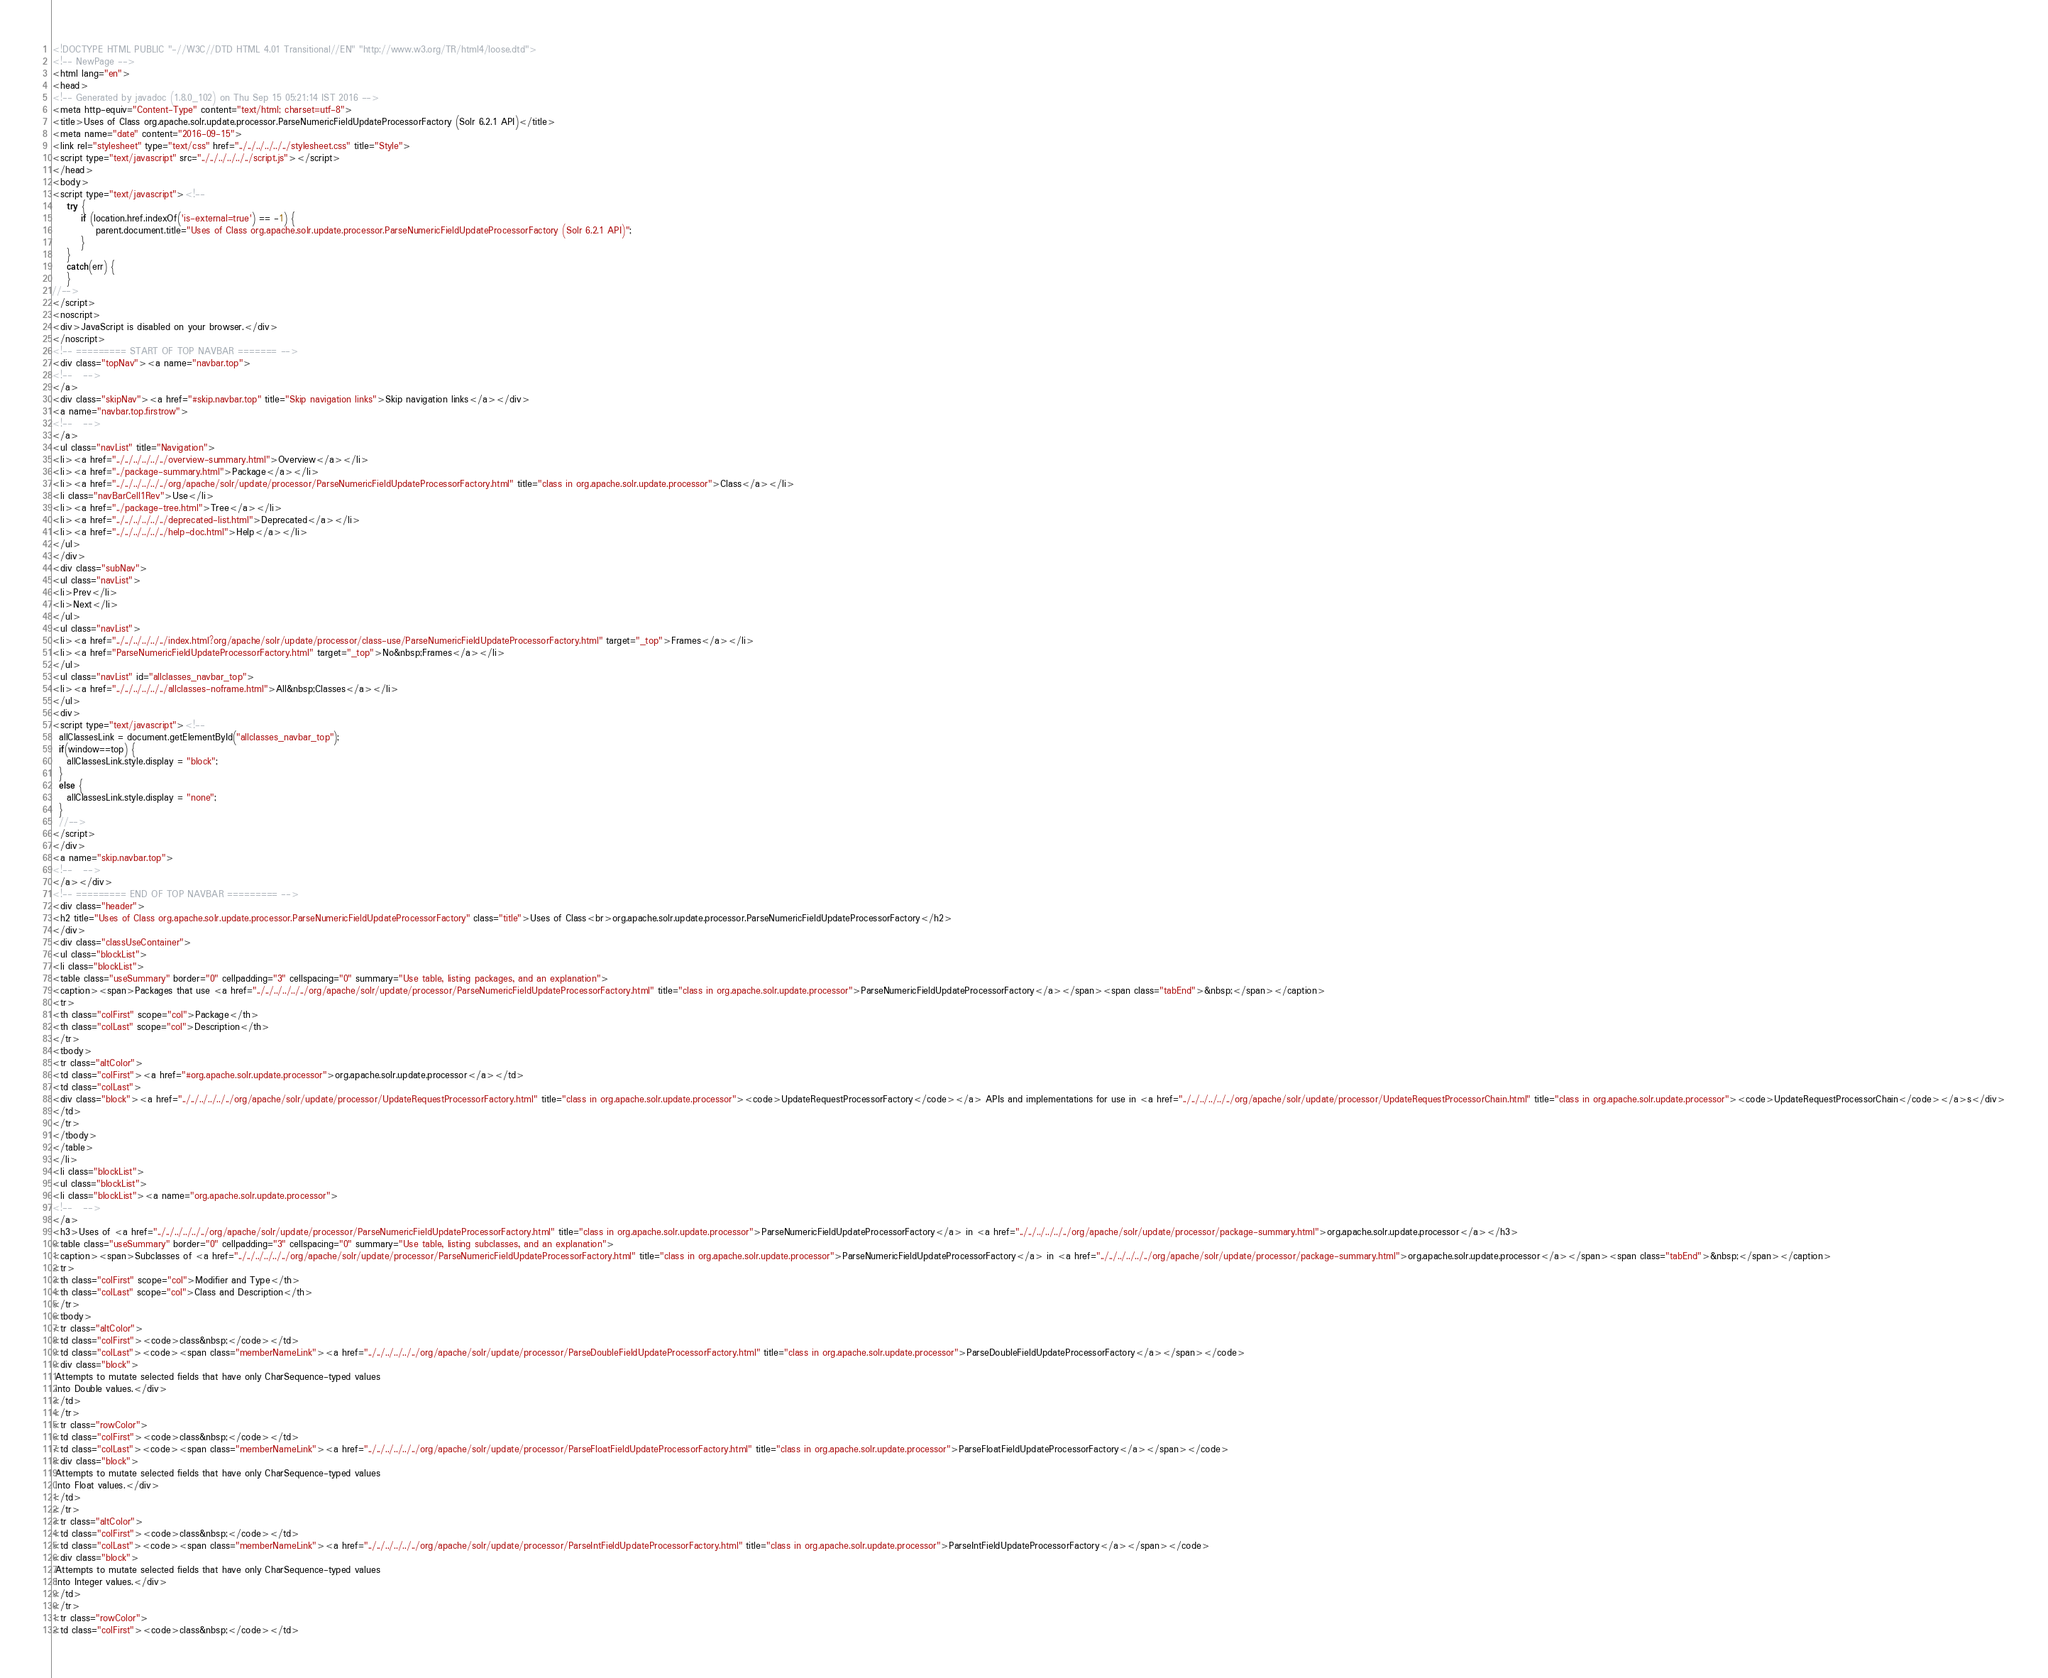<code> <loc_0><loc_0><loc_500><loc_500><_HTML_><!DOCTYPE HTML PUBLIC "-//W3C//DTD HTML 4.01 Transitional//EN" "http://www.w3.org/TR/html4/loose.dtd">
<!-- NewPage -->
<html lang="en">
<head>
<!-- Generated by javadoc (1.8.0_102) on Thu Sep 15 05:21:14 IST 2016 -->
<meta http-equiv="Content-Type" content="text/html; charset=utf-8">
<title>Uses of Class org.apache.solr.update.processor.ParseNumericFieldUpdateProcessorFactory (Solr 6.2.1 API)</title>
<meta name="date" content="2016-09-15">
<link rel="stylesheet" type="text/css" href="../../../../../../stylesheet.css" title="Style">
<script type="text/javascript" src="../../../../../../script.js"></script>
</head>
<body>
<script type="text/javascript"><!--
    try {
        if (location.href.indexOf('is-external=true') == -1) {
            parent.document.title="Uses of Class org.apache.solr.update.processor.ParseNumericFieldUpdateProcessorFactory (Solr 6.2.1 API)";
        }
    }
    catch(err) {
    }
//-->
</script>
<noscript>
<div>JavaScript is disabled on your browser.</div>
</noscript>
<!-- ========= START OF TOP NAVBAR ======= -->
<div class="topNav"><a name="navbar.top">
<!--   -->
</a>
<div class="skipNav"><a href="#skip.navbar.top" title="Skip navigation links">Skip navigation links</a></div>
<a name="navbar.top.firstrow">
<!--   -->
</a>
<ul class="navList" title="Navigation">
<li><a href="../../../../../../overview-summary.html">Overview</a></li>
<li><a href="../package-summary.html">Package</a></li>
<li><a href="../../../../../../org/apache/solr/update/processor/ParseNumericFieldUpdateProcessorFactory.html" title="class in org.apache.solr.update.processor">Class</a></li>
<li class="navBarCell1Rev">Use</li>
<li><a href="../package-tree.html">Tree</a></li>
<li><a href="../../../../../../deprecated-list.html">Deprecated</a></li>
<li><a href="../../../../../../help-doc.html">Help</a></li>
</ul>
</div>
<div class="subNav">
<ul class="navList">
<li>Prev</li>
<li>Next</li>
</ul>
<ul class="navList">
<li><a href="../../../../../../index.html?org/apache/solr/update/processor/class-use/ParseNumericFieldUpdateProcessorFactory.html" target="_top">Frames</a></li>
<li><a href="ParseNumericFieldUpdateProcessorFactory.html" target="_top">No&nbsp;Frames</a></li>
</ul>
<ul class="navList" id="allclasses_navbar_top">
<li><a href="../../../../../../allclasses-noframe.html">All&nbsp;Classes</a></li>
</ul>
<div>
<script type="text/javascript"><!--
  allClassesLink = document.getElementById("allclasses_navbar_top");
  if(window==top) {
    allClassesLink.style.display = "block";
  }
  else {
    allClassesLink.style.display = "none";
  }
  //-->
</script>
</div>
<a name="skip.navbar.top">
<!--   -->
</a></div>
<!-- ========= END OF TOP NAVBAR ========= -->
<div class="header">
<h2 title="Uses of Class org.apache.solr.update.processor.ParseNumericFieldUpdateProcessorFactory" class="title">Uses of Class<br>org.apache.solr.update.processor.ParseNumericFieldUpdateProcessorFactory</h2>
</div>
<div class="classUseContainer">
<ul class="blockList">
<li class="blockList">
<table class="useSummary" border="0" cellpadding="3" cellspacing="0" summary="Use table, listing packages, and an explanation">
<caption><span>Packages that use <a href="../../../../../../org/apache/solr/update/processor/ParseNumericFieldUpdateProcessorFactory.html" title="class in org.apache.solr.update.processor">ParseNumericFieldUpdateProcessorFactory</a></span><span class="tabEnd">&nbsp;</span></caption>
<tr>
<th class="colFirst" scope="col">Package</th>
<th class="colLast" scope="col">Description</th>
</tr>
<tbody>
<tr class="altColor">
<td class="colFirst"><a href="#org.apache.solr.update.processor">org.apache.solr.update.processor</a></td>
<td class="colLast">
<div class="block"><a href="../../../../../../org/apache/solr/update/processor/UpdateRequestProcessorFactory.html" title="class in org.apache.solr.update.processor"><code>UpdateRequestProcessorFactory</code></a> APIs and implementations for use in <a href="../../../../../../org/apache/solr/update/processor/UpdateRequestProcessorChain.html" title="class in org.apache.solr.update.processor"><code>UpdateRequestProcessorChain</code></a>s</div>
</td>
</tr>
</tbody>
</table>
</li>
<li class="blockList">
<ul class="blockList">
<li class="blockList"><a name="org.apache.solr.update.processor">
<!--   -->
</a>
<h3>Uses of <a href="../../../../../../org/apache/solr/update/processor/ParseNumericFieldUpdateProcessorFactory.html" title="class in org.apache.solr.update.processor">ParseNumericFieldUpdateProcessorFactory</a> in <a href="../../../../../../org/apache/solr/update/processor/package-summary.html">org.apache.solr.update.processor</a></h3>
<table class="useSummary" border="0" cellpadding="3" cellspacing="0" summary="Use table, listing subclasses, and an explanation">
<caption><span>Subclasses of <a href="../../../../../../org/apache/solr/update/processor/ParseNumericFieldUpdateProcessorFactory.html" title="class in org.apache.solr.update.processor">ParseNumericFieldUpdateProcessorFactory</a> in <a href="../../../../../../org/apache/solr/update/processor/package-summary.html">org.apache.solr.update.processor</a></span><span class="tabEnd">&nbsp;</span></caption>
<tr>
<th class="colFirst" scope="col">Modifier and Type</th>
<th class="colLast" scope="col">Class and Description</th>
</tr>
<tbody>
<tr class="altColor">
<td class="colFirst"><code>class&nbsp;</code></td>
<td class="colLast"><code><span class="memberNameLink"><a href="../../../../../../org/apache/solr/update/processor/ParseDoubleFieldUpdateProcessorFactory.html" title="class in org.apache.solr.update.processor">ParseDoubleFieldUpdateProcessorFactory</a></span></code>
<div class="block">
 Attempts to mutate selected fields that have only CharSequence-typed values
 into Double values.</div>
</td>
</tr>
<tr class="rowColor">
<td class="colFirst"><code>class&nbsp;</code></td>
<td class="colLast"><code><span class="memberNameLink"><a href="../../../../../../org/apache/solr/update/processor/ParseFloatFieldUpdateProcessorFactory.html" title="class in org.apache.solr.update.processor">ParseFloatFieldUpdateProcessorFactory</a></span></code>
<div class="block">
 Attempts to mutate selected fields that have only CharSequence-typed values
 into Float values.</div>
</td>
</tr>
<tr class="altColor">
<td class="colFirst"><code>class&nbsp;</code></td>
<td class="colLast"><code><span class="memberNameLink"><a href="../../../../../../org/apache/solr/update/processor/ParseIntFieldUpdateProcessorFactory.html" title="class in org.apache.solr.update.processor">ParseIntFieldUpdateProcessorFactory</a></span></code>
<div class="block">
 Attempts to mutate selected fields that have only CharSequence-typed values
 into Integer values.</div>
</td>
</tr>
<tr class="rowColor">
<td class="colFirst"><code>class&nbsp;</code></td></code> 